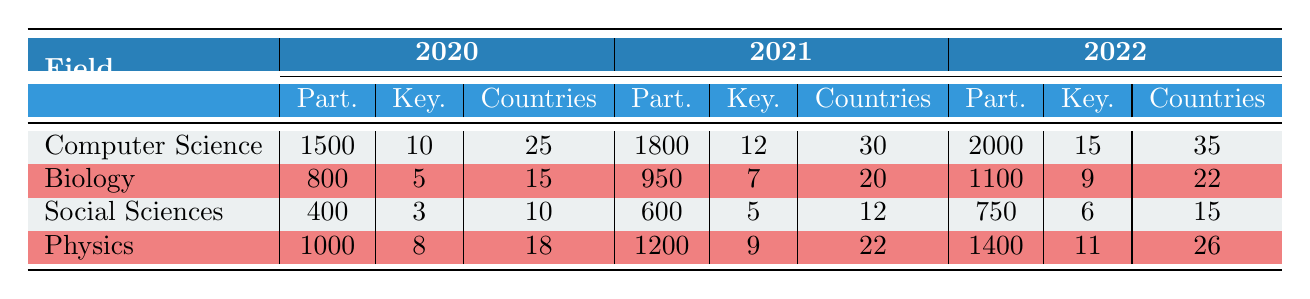What was the total number of participants in Computer Science across all three years? In the table, the number of participants in Computer Science for the years 2020, 2021, and 2022 are 1500, 1800, and 2000 respectively. Adding these numbers gives 1500 + 1800 + 2000 = 5300.
Answer: 5300 In which year did Physics have the highest representation of countries? The table shows the number of countries represented in Physics for 2020, 2021, and 2022 as 18, 22, and 26 respectively. The highest value is 26 in 2022.
Answer: 2022 How many more keynotes were there in Computer Science in 2022 compared to 2020? The number of keynotes in Computer Science was 10 in 2020 and 15 in 2022. To find the difference, subtract 10 from 15 which gives 15 - 10 = 5.
Answer: 5 Is it true that Biology had more keynotes in 2021 than Social Sciences in the same year? In 2021, Biology had 7 keynotes while Social Sciences had 5 keynotes. Since 7 is greater than 5, the statement is true.
Answer: Yes What is the average number of participants across all fields in 2021? To find the average for 2021, first sum the participants from all fields: Computer Science (1800) + Biology (950) + Social Sciences (600) + Physics (1200) = 3550. There are 4 fields, so divide the total by 4: 3550 / 4 = 887.5.
Answer: 887.5 How many countries were represented in total across all fields in 2020? The table shows that in 2020, the countries represented were Computer Science (25), Biology (15), Social Sciences (10), and Physics (18). The total is 25 + 15 + 10 + 18 = 68.
Answer: 68 How many keynotes did Social Sciences have in the year with the least participants? In the table, Social Sciences had 400 participants in 2020, which is the lowest. In that year, they had 3 keynotes.
Answer: 3 In which field did the number of participants decrease the least between 2021 and 2022? For each field, the differences are as follows: Computer Science increased by 200, Biology increased by 150, Social Sciences increased by 150, and Physics increased by 200. Since all fields increased, we confirm that the changes were all positive with no decreases.
Answer: None (all increased) 